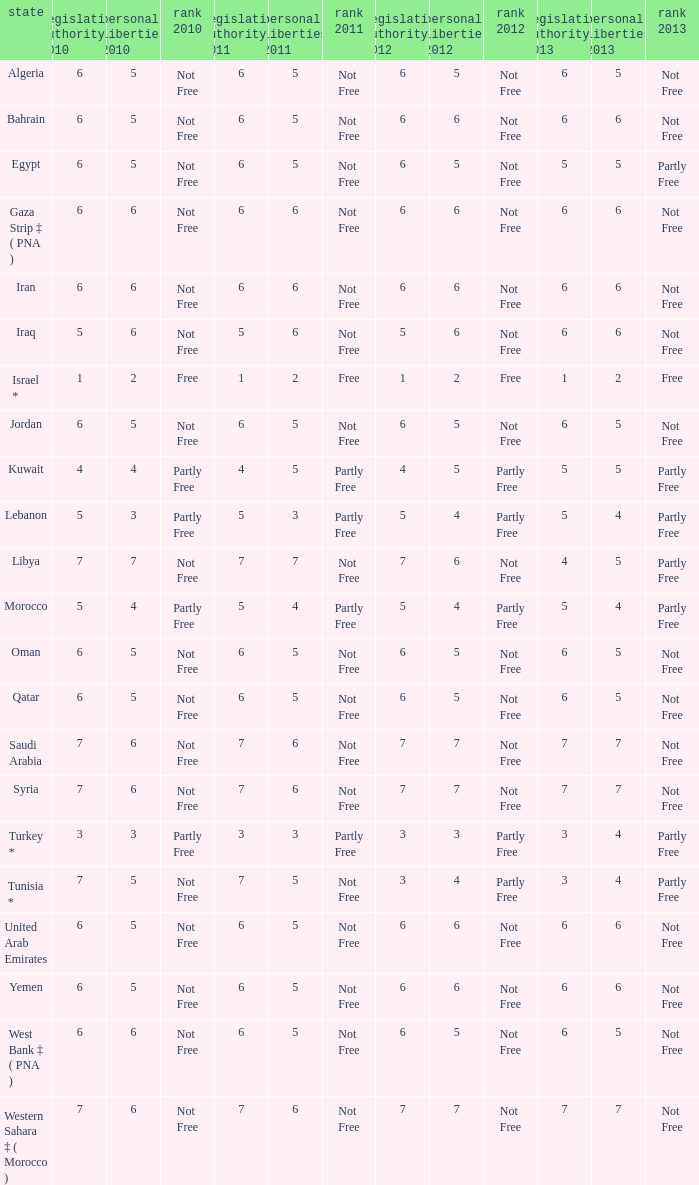What is the average 2012 civil liberties value associated with a 2011 status of not free, political rights 2012 over 6, and political rights 2011 over 7? None. 